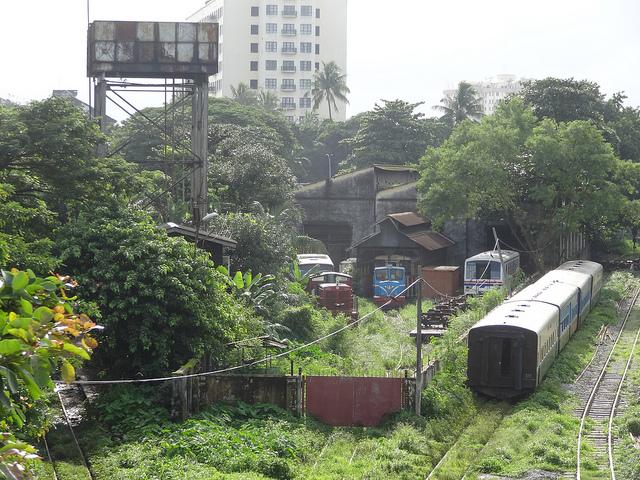Is this train yard in use?
Keep it brief. No. Where is the tall palm tree?
Concise answer only. Background. What color is the tallest building visible in the background?
Give a very brief answer. White. 